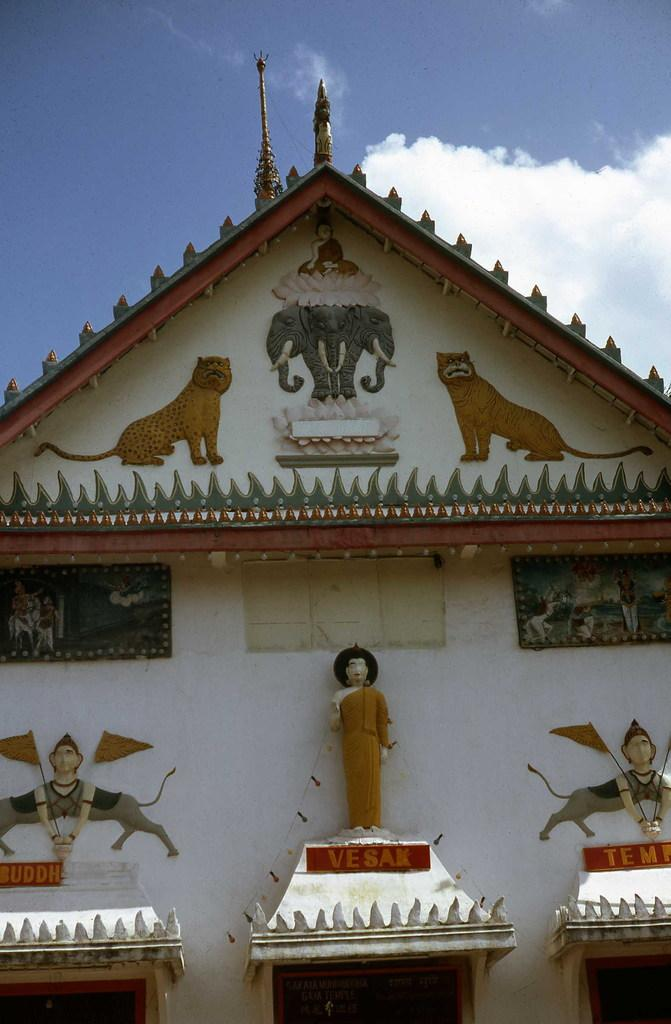What type of artwork can be seen on the wall in the image? There is a carving on the wall in the image. What other type of artwork is present in the image? There is a sculpture in the image. What materials are visible in the image? Boards and poles are present in the image. What is visible at the top of the image? The sky is visible at the top of the image. Where is the faucet located in the image? There is no faucet present in the image. What type of beetle can be seen crawling on the sculpture in the image? There is no beetle present in the image; it only features a sculpture and a carving on the wall. 